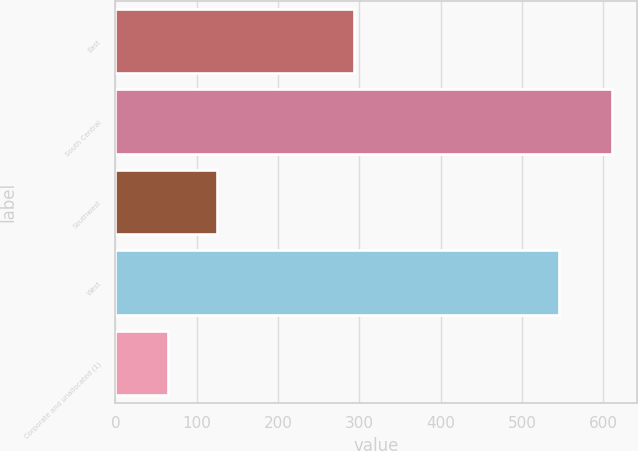Convert chart. <chart><loc_0><loc_0><loc_500><loc_500><bar_chart><fcel>East<fcel>South Central<fcel>Southwest<fcel>West<fcel>Corporate and unallocated (1)<nl><fcel>293.5<fcel>610.3<fcel>124.6<fcel>545.8<fcel>64.3<nl></chart> 